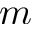Convert formula to latex. <formula><loc_0><loc_0><loc_500><loc_500>m</formula> 